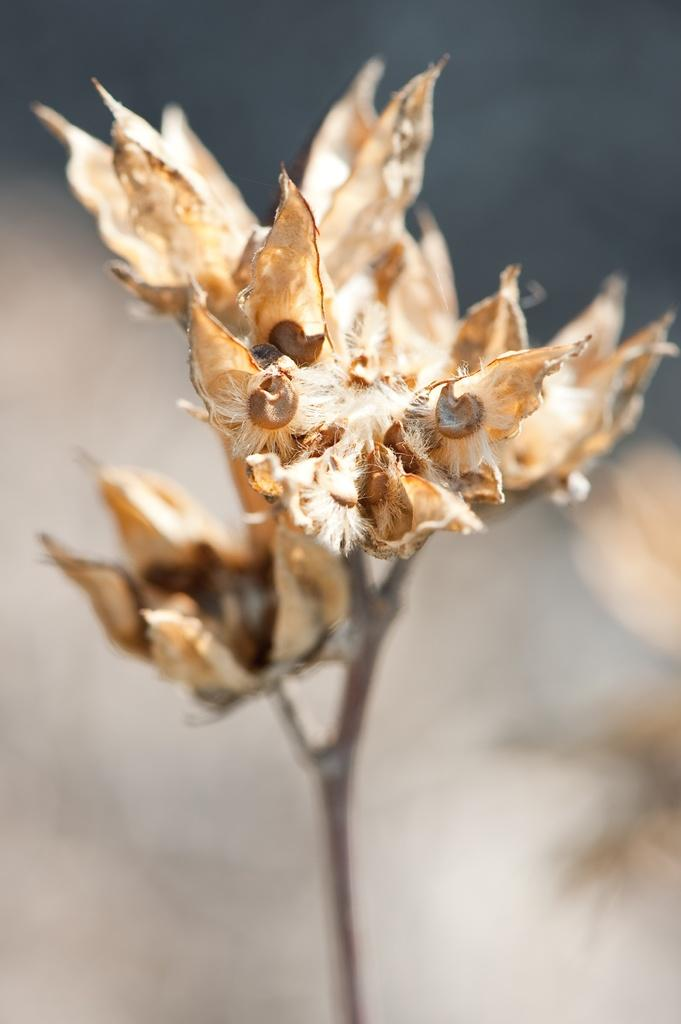What is the main subject of the image? There is a plant in the image. Can you describe the background of the image? The background of the image is blurred. What type of protest is taking place in the image? There is no protest present in the image; it features a plant and a blurred background. How many hens can be seen in the image? There are no hens present in the image. 